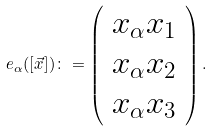<formula> <loc_0><loc_0><loc_500><loc_500>e _ { \alpha } ( [ \vec { x } ] ) \colon = \left ( \begin{array} { c } x _ { \alpha } x _ { 1 } \\ x _ { \alpha } x _ { 2 } \\ x _ { \alpha } x _ { 3 } \end{array} \right ) .</formula> 